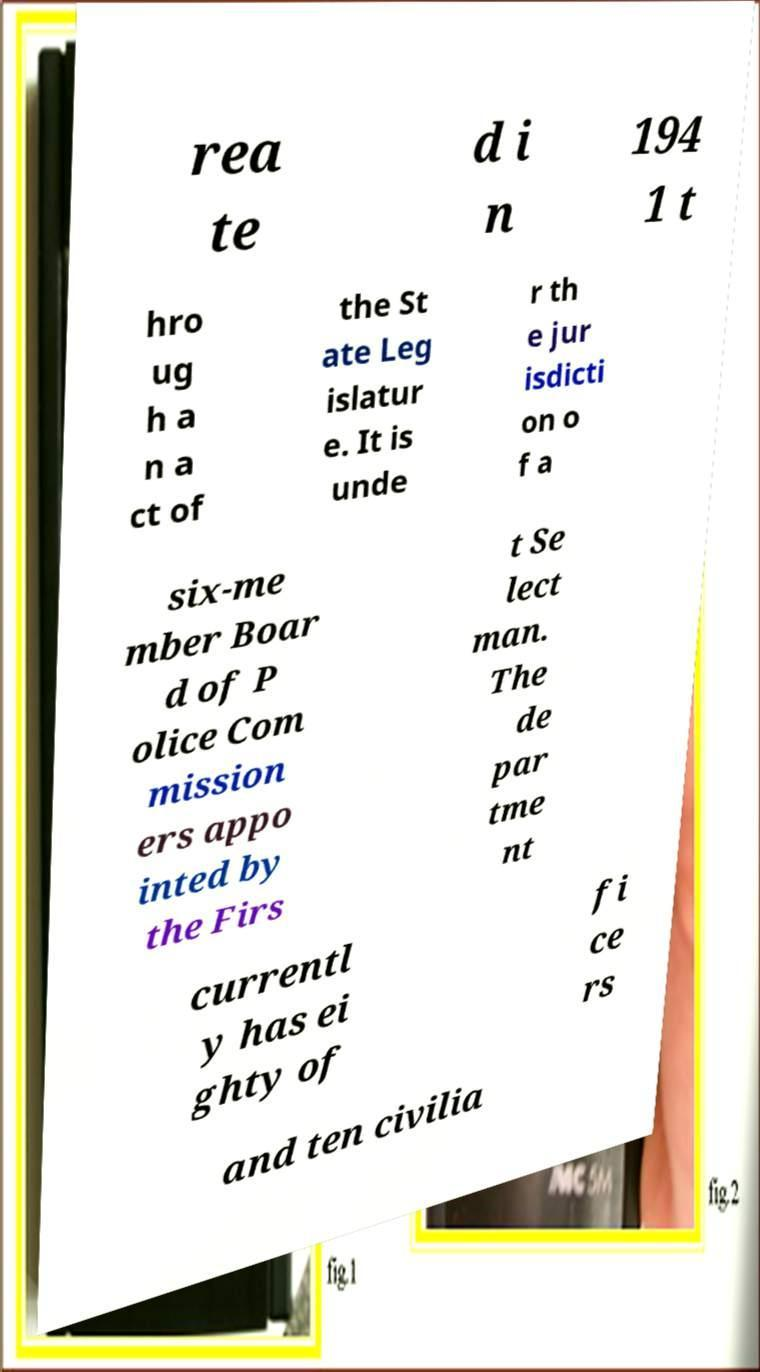Please read and relay the text visible in this image. What does it say? rea te d i n 194 1 t hro ug h a n a ct of the St ate Leg islatur e. It is unde r th e jur isdicti on o f a six-me mber Boar d of P olice Com mission ers appo inted by the Firs t Se lect man. The de par tme nt currentl y has ei ghty of fi ce rs and ten civilia 